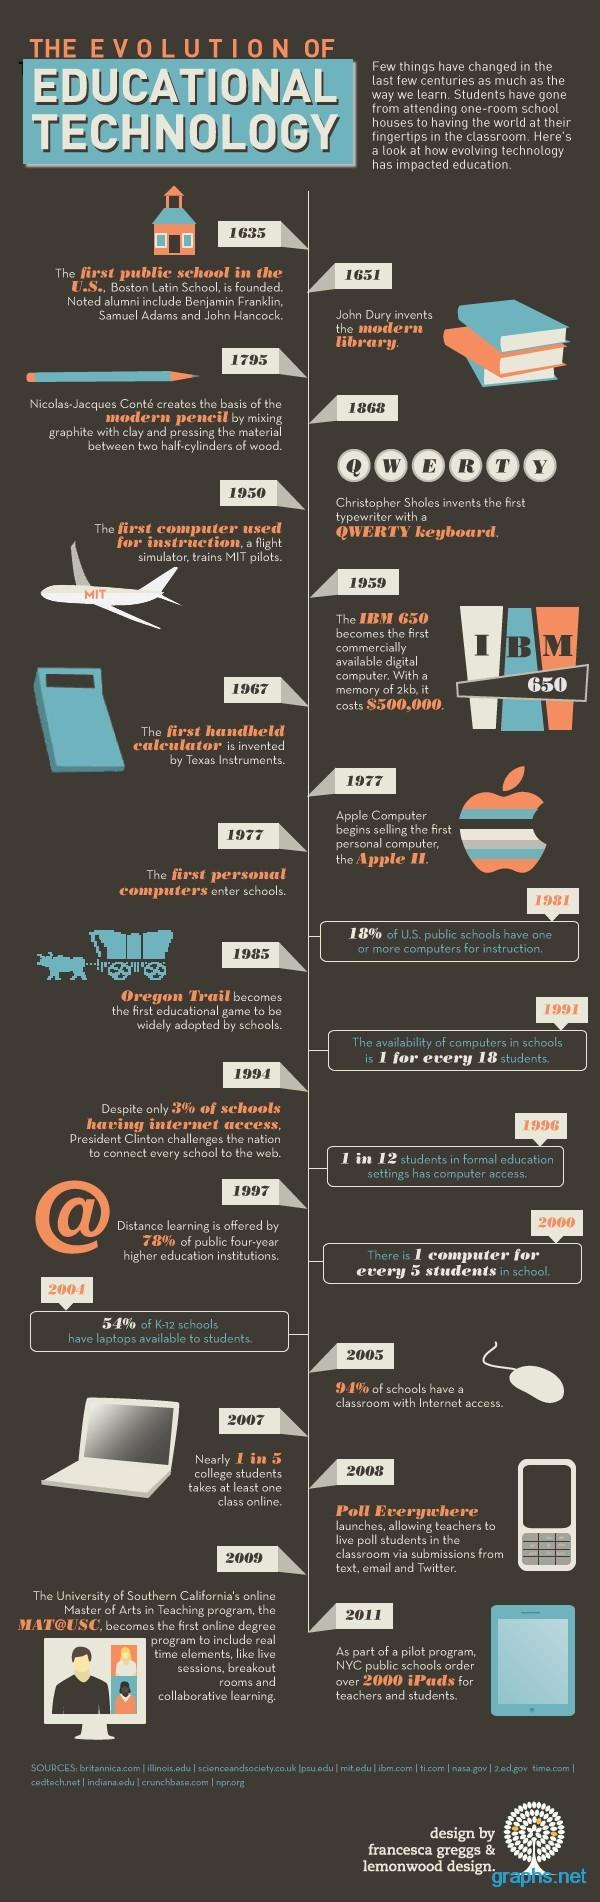Point out several critical features in this image. In 1967, the first handheld calculator was invented. The first computer used for instruction was in 1950. John Dury invented the modern library in 1651. By 1997, 78% of higher education institutions were offering distance learning. The modern pencil was created in the year 1795. 